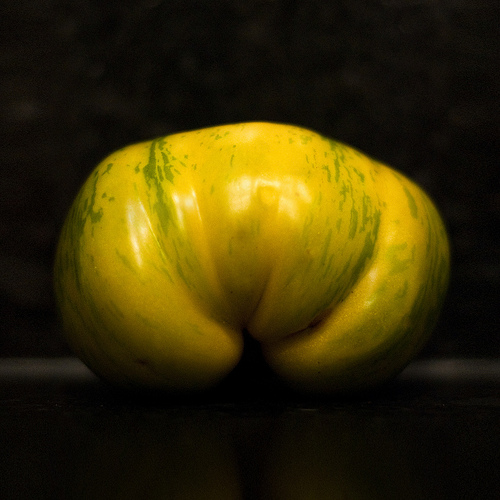<image>
Is the fruit under the dark room? No. The fruit is not positioned under the dark room. The vertical relationship between these objects is different. 